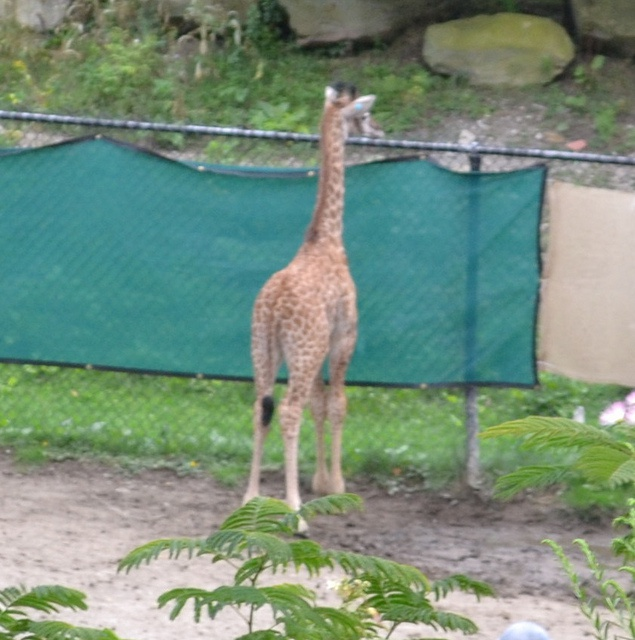Describe the objects in this image and their specific colors. I can see a giraffe in darkgray, tan, and gray tones in this image. 